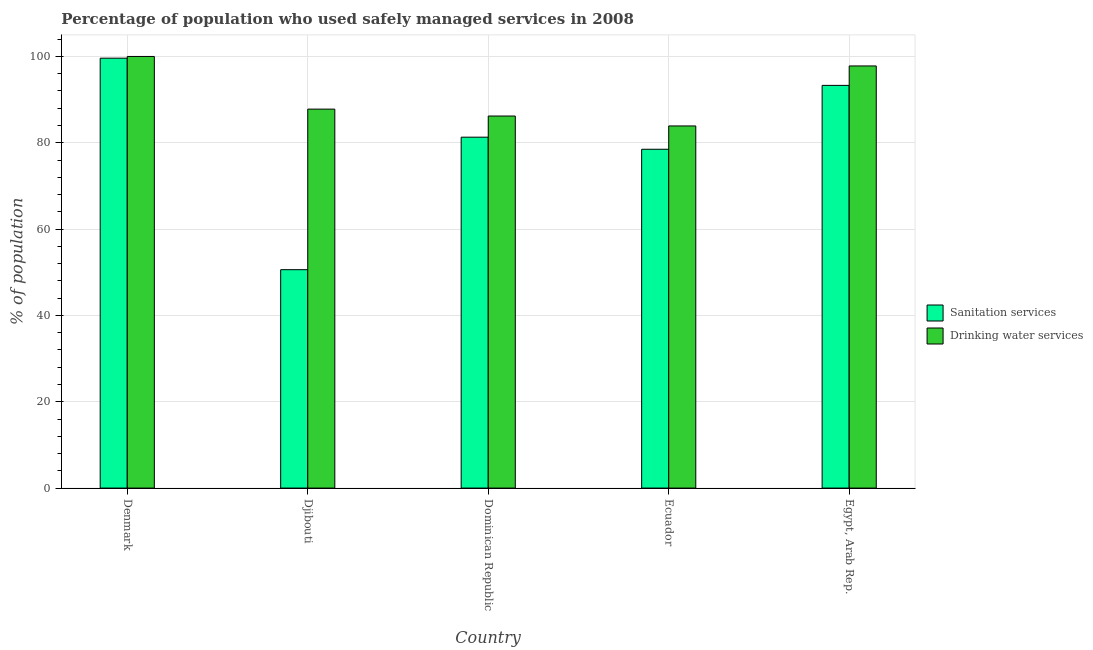Are the number of bars per tick equal to the number of legend labels?
Make the answer very short. Yes. Are the number of bars on each tick of the X-axis equal?
Ensure brevity in your answer.  Yes. How many bars are there on the 1st tick from the right?
Provide a short and direct response. 2. What is the label of the 4th group of bars from the left?
Make the answer very short. Ecuador. What is the percentage of population who used sanitation services in Ecuador?
Ensure brevity in your answer.  78.5. Across all countries, what is the maximum percentage of population who used drinking water services?
Offer a terse response. 100. Across all countries, what is the minimum percentage of population who used drinking water services?
Your response must be concise. 83.9. In which country was the percentage of population who used drinking water services minimum?
Provide a succinct answer. Ecuador. What is the total percentage of population who used drinking water services in the graph?
Your response must be concise. 455.7. What is the difference between the percentage of population who used sanitation services in Denmark and that in Dominican Republic?
Provide a short and direct response. 18.3. What is the difference between the percentage of population who used sanitation services in Denmark and the percentage of population who used drinking water services in Djibouti?
Ensure brevity in your answer.  11.8. What is the average percentage of population who used drinking water services per country?
Offer a very short reply. 91.14. What is the difference between the percentage of population who used sanitation services and percentage of population who used drinking water services in Ecuador?
Your answer should be compact. -5.4. What is the ratio of the percentage of population who used drinking water services in Djibouti to that in Ecuador?
Make the answer very short. 1.05. Is the percentage of population who used sanitation services in Dominican Republic less than that in Ecuador?
Offer a terse response. No. What is the difference between the highest and the second highest percentage of population who used sanitation services?
Your answer should be compact. 6.3. What is the difference between the highest and the lowest percentage of population who used drinking water services?
Your answer should be compact. 16.1. In how many countries, is the percentage of population who used sanitation services greater than the average percentage of population who used sanitation services taken over all countries?
Your response must be concise. 3. Is the sum of the percentage of population who used drinking water services in Djibouti and Egypt, Arab Rep. greater than the maximum percentage of population who used sanitation services across all countries?
Your answer should be very brief. Yes. What does the 1st bar from the left in Denmark represents?
Provide a short and direct response. Sanitation services. What does the 1st bar from the right in Djibouti represents?
Provide a succinct answer. Drinking water services. Are all the bars in the graph horizontal?
Provide a short and direct response. No. How many countries are there in the graph?
Your response must be concise. 5. What is the difference between two consecutive major ticks on the Y-axis?
Your answer should be very brief. 20. Are the values on the major ticks of Y-axis written in scientific E-notation?
Ensure brevity in your answer.  No. Does the graph contain any zero values?
Provide a succinct answer. No. Does the graph contain grids?
Your response must be concise. Yes. Where does the legend appear in the graph?
Provide a short and direct response. Center right. What is the title of the graph?
Offer a very short reply. Percentage of population who used safely managed services in 2008. Does "UN agencies" appear as one of the legend labels in the graph?
Provide a succinct answer. No. What is the label or title of the X-axis?
Provide a short and direct response. Country. What is the label or title of the Y-axis?
Provide a succinct answer. % of population. What is the % of population of Sanitation services in Denmark?
Keep it short and to the point. 99.6. What is the % of population of Sanitation services in Djibouti?
Keep it short and to the point. 50.6. What is the % of population of Drinking water services in Djibouti?
Your answer should be very brief. 87.8. What is the % of population of Sanitation services in Dominican Republic?
Make the answer very short. 81.3. What is the % of population in Drinking water services in Dominican Republic?
Make the answer very short. 86.2. What is the % of population of Sanitation services in Ecuador?
Your response must be concise. 78.5. What is the % of population in Drinking water services in Ecuador?
Keep it short and to the point. 83.9. What is the % of population of Sanitation services in Egypt, Arab Rep.?
Your answer should be very brief. 93.3. What is the % of population in Drinking water services in Egypt, Arab Rep.?
Keep it short and to the point. 97.8. Across all countries, what is the maximum % of population in Sanitation services?
Make the answer very short. 99.6. Across all countries, what is the maximum % of population of Drinking water services?
Keep it short and to the point. 100. Across all countries, what is the minimum % of population of Sanitation services?
Offer a terse response. 50.6. Across all countries, what is the minimum % of population of Drinking water services?
Provide a succinct answer. 83.9. What is the total % of population in Sanitation services in the graph?
Make the answer very short. 403.3. What is the total % of population of Drinking water services in the graph?
Offer a terse response. 455.7. What is the difference between the % of population in Sanitation services in Denmark and that in Djibouti?
Give a very brief answer. 49. What is the difference between the % of population of Drinking water services in Denmark and that in Djibouti?
Your answer should be compact. 12.2. What is the difference between the % of population of Sanitation services in Denmark and that in Dominican Republic?
Your answer should be compact. 18.3. What is the difference between the % of population in Drinking water services in Denmark and that in Dominican Republic?
Your answer should be very brief. 13.8. What is the difference between the % of population in Sanitation services in Denmark and that in Ecuador?
Your answer should be compact. 21.1. What is the difference between the % of population in Sanitation services in Denmark and that in Egypt, Arab Rep.?
Give a very brief answer. 6.3. What is the difference between the % of population in Sanitation services in Djibouti and that in Dominican Republic?
Make the answer very short. -30.7. What is the difference between the % of population of Drinking water services in Djibouti and that in Dominican Republic?
Provide a short and direct response. 1.6. What is the difference between the % of population in Sanitation services in Djibouti and that in Ecuador?
Provide a succinct answer. -27.9. What is the difference between the % of population of Sanitation services in Djibouti and that in Egypt, Arab Rep.?
Give a very brief answer. -42.7. What is the difference between the % of population of Sanitation services in Dominican Republic and that in Ecuador?
Your answer should be very brief. 2.8. What is the difference between the % of population of Drinking water services in Dominican Republic and that in Egypt, Arab Rep.?
Your answer should be compact. -11.6. What is the difference between the % of population in Sanitation services in Ecuador and that in Egypt, Arab Rep.?
Your answer should be very brief. -14.8. What is the difference between the % of population of Drinking water services in Ecuador and that in Egypt, Arab Rep.?
Make the answer very short. -13.9. What is the difference between the % of population in Sanitation services in Denmark and the % of population in Drinking water services in Dominican Republic?
Your answer should be very brief. 13.4. What is the difference between the % of population of Sanitation services in Denmark and the % of population of Drinking water services in Ecuador?
Your answer should be very brief. 15.7. What is the difference between the % of population of Sanitation services in Djibouti and the % of population of Drinking water services in Dominican Republic?
Provide a short and direct response. -35.6. What is the difference between the % of population in Sanitation services in Djibouti and the % of population in Drinking water services in Ecuador?
Offer a very short reply. -33.3. What is the difference between the % of population in Sanitation services in Djibouti and the % of population in Drinking water services in Egypt, Arab Rep.?
Provide a succinct answer. -47.2. What is the difference between the % of population in Sanitation services in Dominican Republic and the % of population in Drinking water services in Egypt, Arab Rep.?
Keep it short and to the point. -16.5. What is the difference between the % of population of Sanitation services in Ecuador and the % of population of Drinking water services in Egypt, Arab Rep.?
Provide a succinct answer. -19.3. What is the average % of population of Sanitation services per country?
Your answer should be compact. 80.66. What is the average % of population of Drinking water services per country?
Ensure brevity in your answer.  91.14. What is the difference between the % of population in Sanitation services and % of population in Drinking water services in Djibouti?
Keep it short and to the point. -37.2. What is the ratio of the % of population of Sanitation services in Denmark to that in Djibouti?
Provide a succinct answer. 1.97. What is the ratio of the % of population in Drinking water services in Denmark to that in Djibouti?
Offer a very short reply. 1.14. What is the ratio of the % of population in Sanitation services in Denmark to that in Dominican Republic?
Your answer should be compact. 1.23. What is the ratio of the % of population of Drinking water services in Denmark to that in Dominican Republic?
Keep it short and to the point. 1.16. What is the ratio of the % of population in Sanitation services in Denmark to that in Ecuador?
Your answer should be compact. 1.27. What is the ratio of the % of population of Drinking water services in Denmark to that in Ecuador?
Offer a terse response. 1.19. What is the ratio of the % of population of Sanitation services in Denmark to that in Egypt, Arab Rep.?
Make the answer very short. 1.07. What is the ratio of the % of population of Drinking water services in Denmark to that in Egypt, Arab Rep.?
Give a very brief answer. 1.02. What is the ratio of the % of population in Sanitation services in Djibouti to that in Dominican Republic?
Your answer should be compact. 0.62. What is the ratio of the % of population in Drinking water services in Djibouti to that in Dominican Republic?
Provide a short and direct response. 1.02. What is the ratio of the % of population of Sanitation services in Djibouti to that in Ecuador?
Provide a succinct answer. 0.64. What is the ratio of the % of population of Drinking water services in Djibouti to that in Ecuador?
Offer a terse response. 1.05. What is the ratio of the % of population in Sanitation services in Djibouti to that in Egypt, Arab Rep.?
Make the answer very short. 0.54. What is the ratio of the % of population of Drinking water services in Djibouti to that in Egypt, Arab Rep.?
Offer a terse response. 0.9. What is the ratio of the % of population in Sanitation services in Dominican Republic to that in Ecuador?
Your response must be concise. 1.04. What is the ratio of the % of population of Drinking water services in Dominican Republic to that in Ecuador?
Keep it short and to the point. 1.03. What is the ratio of the % of population in Sanitation services in Dominican Republic to that in Egypt, Arab Rep.?
Make the answer very short. 0.87. What is the ratio of the % of population of Drinking water services in Dominican Republic to that in Egypt, Arab Rep.?
Your answer should be very brief. 0.88. What is the ratio of the % of population of Sanitation services in Ecuador to that in Egypt, Arab Rep.?
Keep it short and to the point. 0.84. What is the ratio of the % of population in Drinking water services in Ecuador to that in Egypt, Arab Rep.?
Your answer should be very brief. 0.86. What is the difference between the highest and the second highest % of population in Sanitation services?
Give a very brief answer. 6.3. What is the difference between the highest and the second highest % of population in Drinking water services?
Ensure brevity in your answer.  2.2. What is the difference between the highest and the lowest % of population of Drinking water services?
Provide a short and direct response. 16.1. 